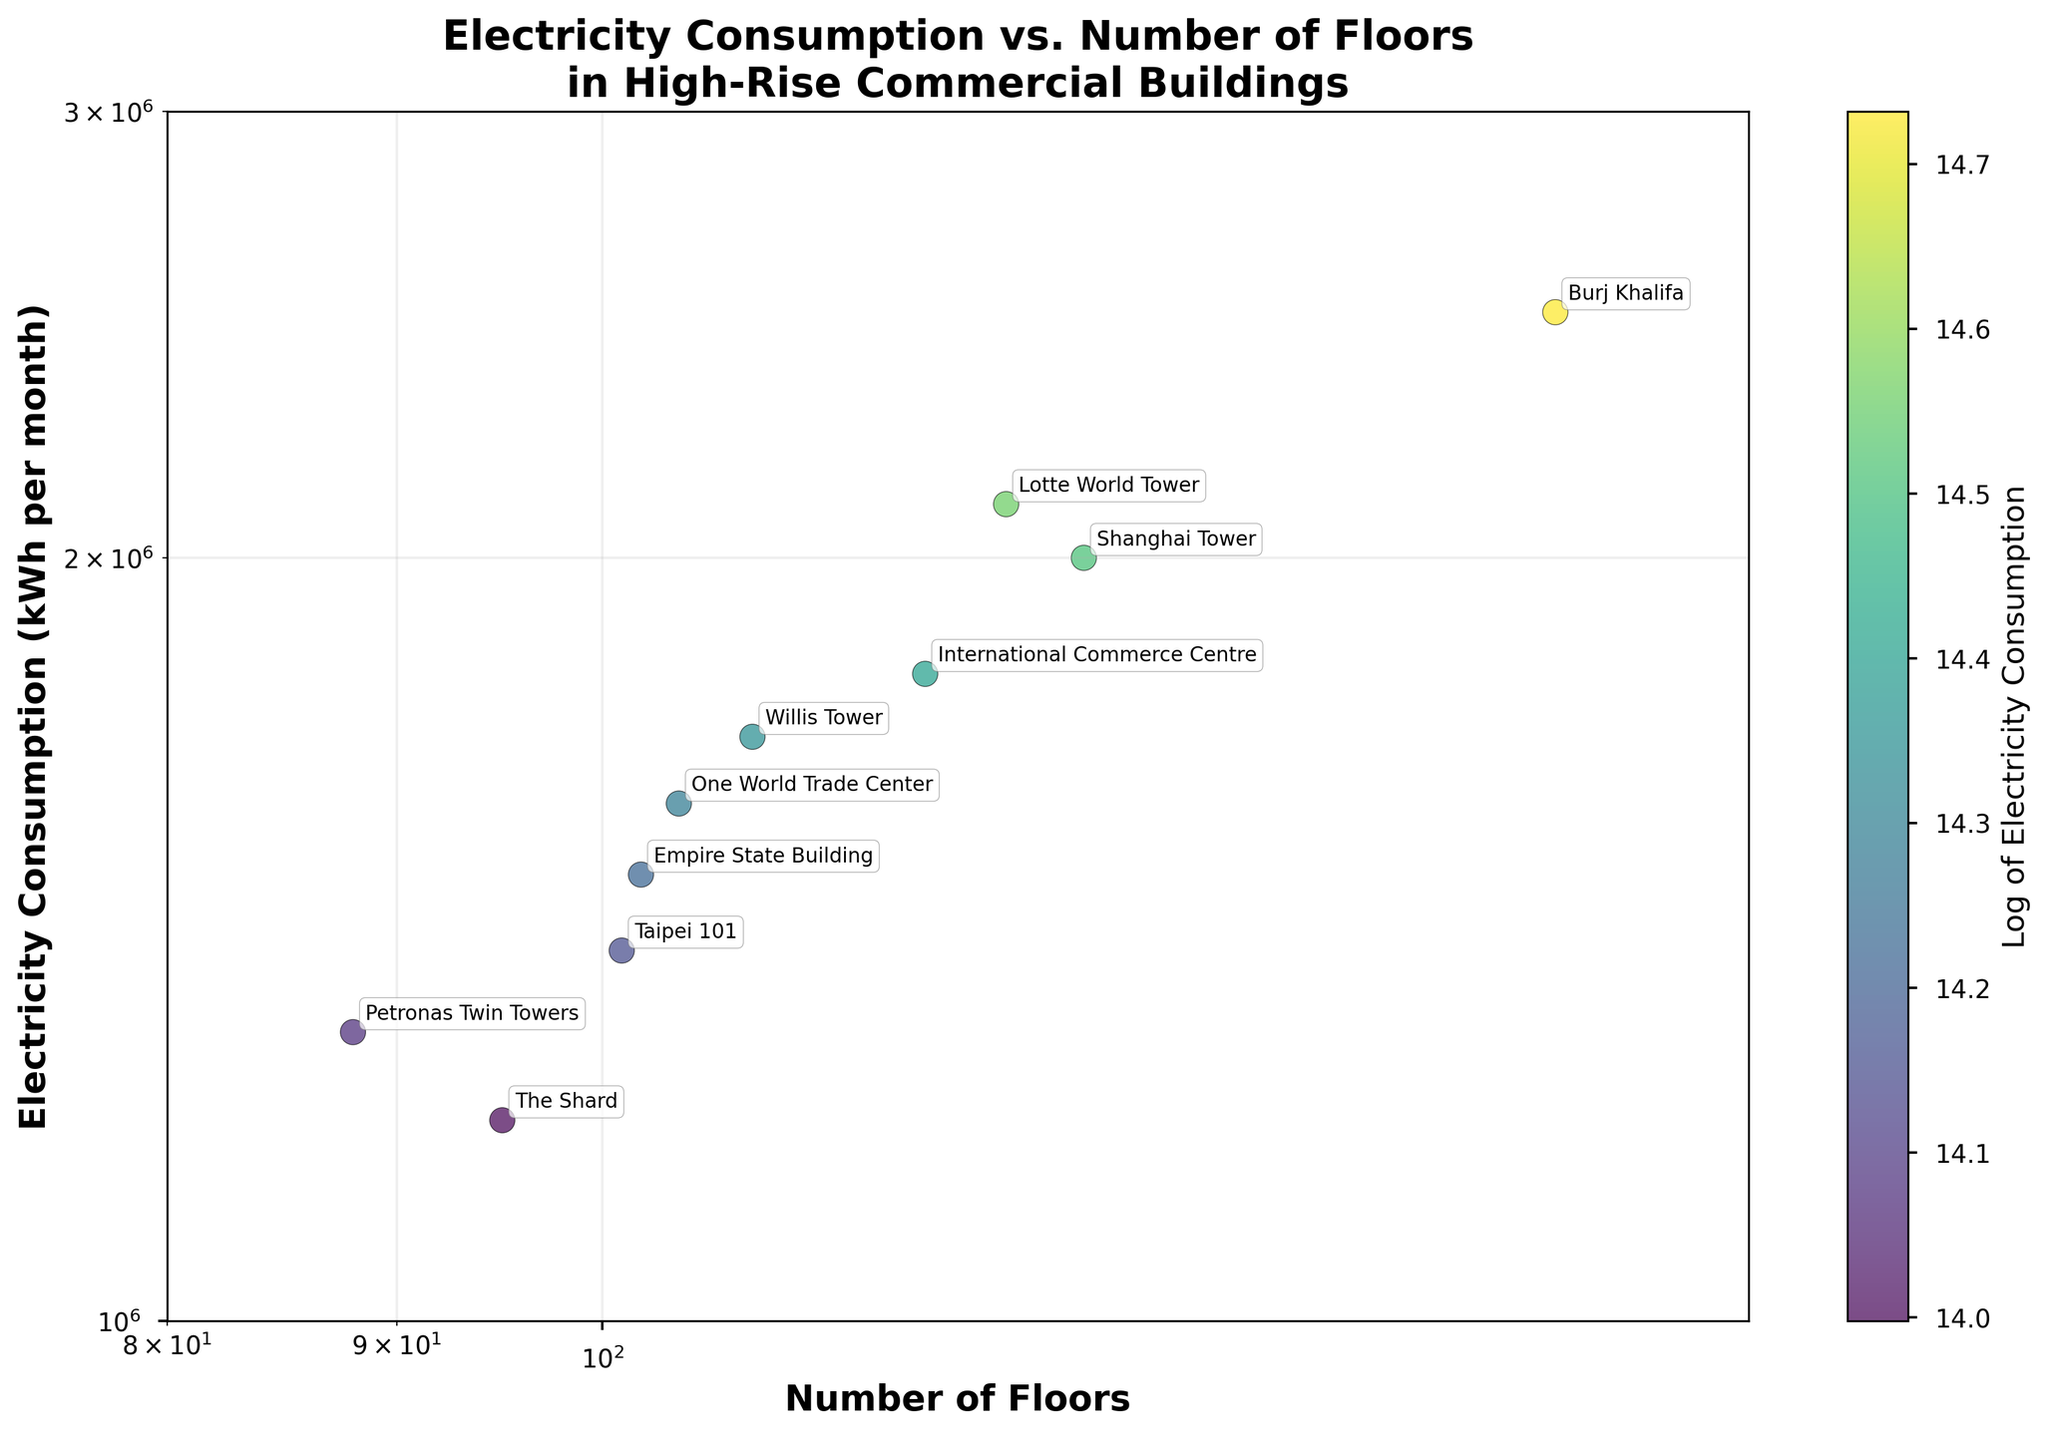How many buildings are represented in the scatter plot? The scatter plot has one point per building, and each building name is annotated on the plot. Counting them gives us the total number of buildings.
Answer: 10 Which building has the highest electricity consumption? From the scatter plot, the point with the highest y-value (electricity consumption) can be identified and its annotation shows the building name.
Answer: Burj Khalifa How does the color of the points relate to the data? The color of the points is based on the logarithm of their electricity consumption, as indicated by the color bar on the right side of the plot. Darker colors represent higher electricity consumption.
Answer: Indicates log of electricity consumption What is the relationship between the number of floors and electricity consumption in the figure? The scatter plot uses log-log scales for both axes, showing a generally positive relationship. As the number of floors increases, the electricity consumption also tends to increase.
Answer: Positive correlation Which building with fewer than 100 floors has the lowest electricity consumption? Checking the points with x-values (number of floors) less than 100, the one with the lowest y-value (electricity consumption) is identified and annotated.
Answer: The Shard What is the range of the number of floors represented in the plot? The x-axis has a range from 80 to 180 (log scale), and the data points fit within this span.
Answer: 88 to 163 Which building with more than 120 floors has the highest electricity consumption? Identifying points with x-values greater than 120, the one with the highest y-value is Burj Khalifa based on the plot annotations and position.
Answer: Burj Khalifa Do buildings with more floors always have higher electricity consumption than those with fewer floors? Analyzing the scatter plot shows some variation, but generally, there is an upward trend. Exceptions like the Petronas Twin Towers illustrate the absence of a strict rule.
Answer: No Is there any building that appears to have an outlier status regarding its electricity consumption? By evaluating the scatter plot, any points that stand significantly apart from the general trend line can be considered outliers. Burj Khalifa has notably high electricity consumption, standing apart from buildings with similar floor numbers.
Answer: Burj Khalifa What is the average electricity consumption of buildings taller than 100 floors? Identify the buildings taller than 100 floors, sum their electricity consumption, and divide by the number of such buildings.
(1500000+1700000+1600000+2500000+2000000+1800000+2100000)/(7 buildings) = 1828571.43
Answer: 1828571.43 